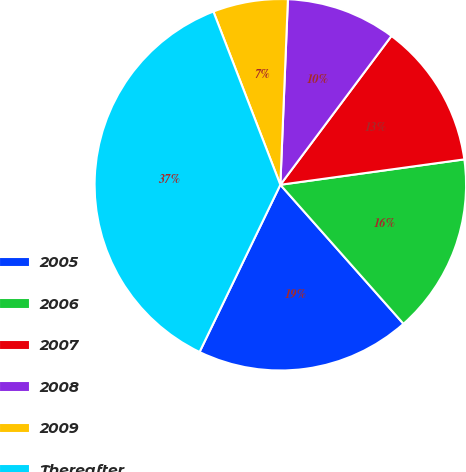Convert chart. <chart><loc_0><loc_0><loc_500><loc_500><pie_chart><fcel>2005<fcel>2006<fcel>2007<fcel>2008<fcel>2009<fcel>Thereafter<nl><fcel>18.7%<fcel>15.65%<fcel>12.61%<fcel>9.56%<fcel>6.52%<fcel>36.97%<nl></chart> 